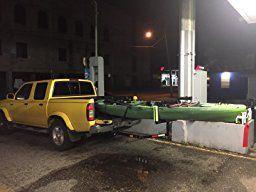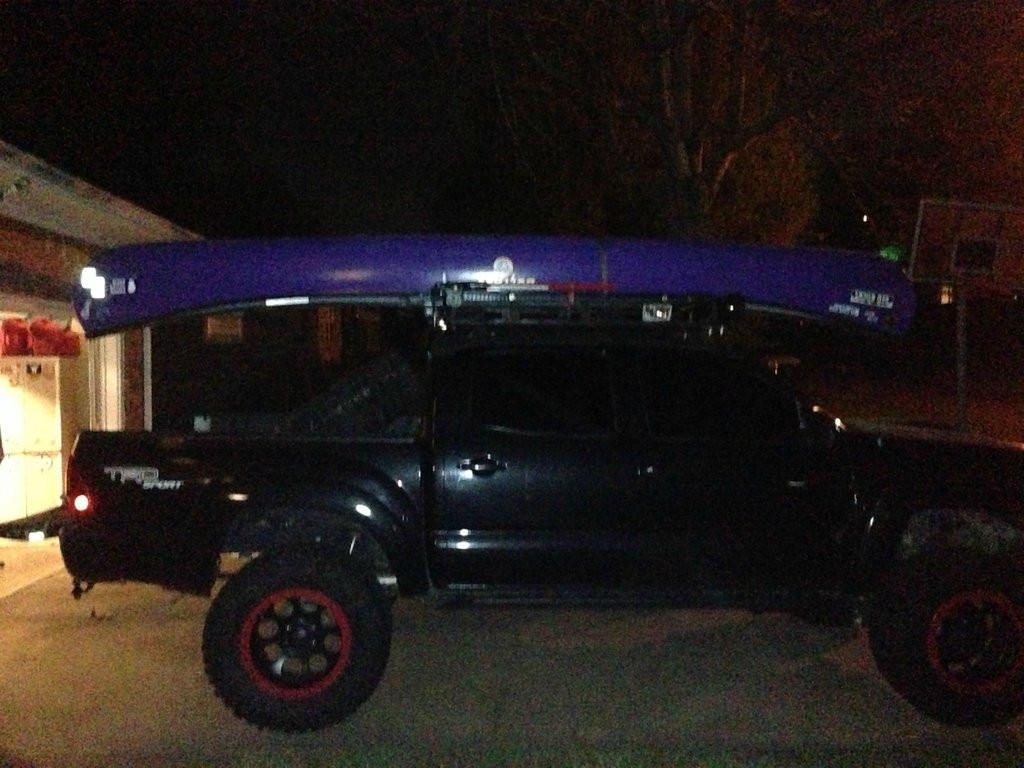The first image is the image on the left, the second image is the image on the right. Considering the images on both sides, is "In the right image there is a truck driving to the left in the daytime." valid? Answer yes or no. No. 